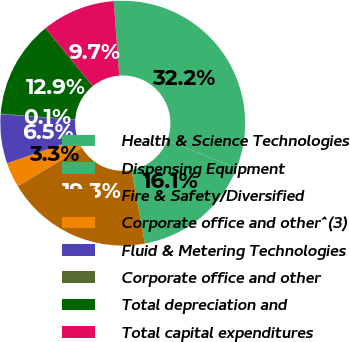<chart> <loc_0><loc_0><loc_500><loc_500><pie_chart><fcel>Health & Science Technologies<fcel>Dispensing Equipment<fcel>Fire & Safety/Diversified<fcel>Corporate office and other^(3)<fcel>Fluid & Metering Technologies<fcel>Corporate office and other<fcel>Total depreciation and<fcel>Total capital expenditures<nl><fcel>32.15%<fcel>16.11%<fcel>19.32%<fcel>3.28%<fcel>6.48%<fcel>0.07%<fcel>12.9%<fcel>9.69%<nl></chart> 